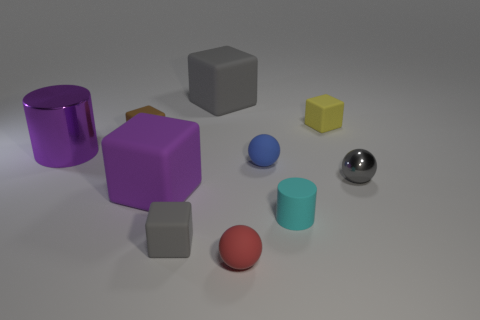Is the number of large objects that are behind the metal cylinder greater than the number of large gray blocks to the right of the red matte object? No, there are two large objects behind the metal cylinder when looking at the scene, while there are three large gray blocks to the right of the red matte object, making the latter the greater amount. 